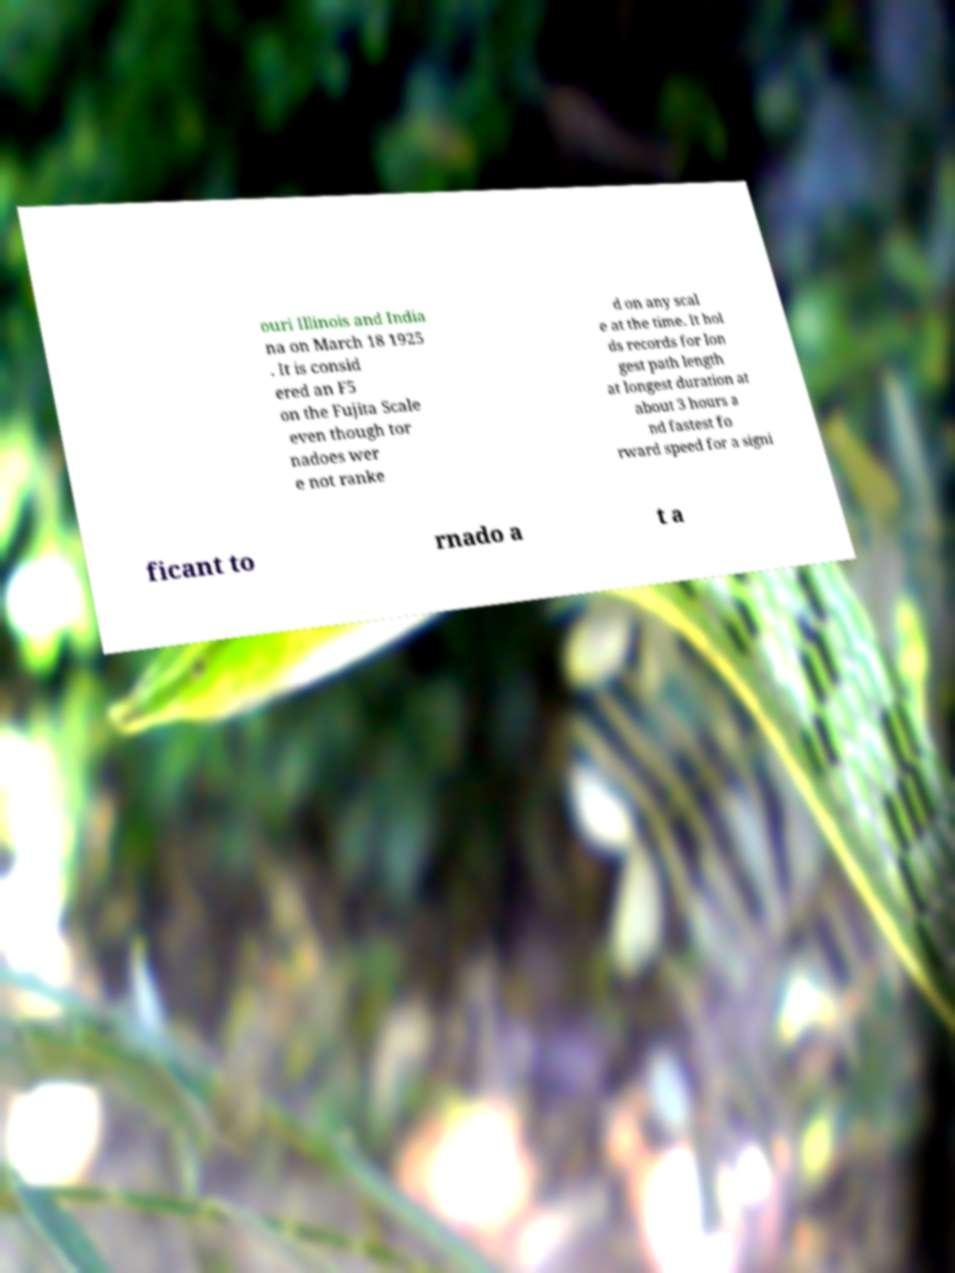Please identify and transcribe the text found in this image. ouri Illinois and India na on March 18 1925 . It is consid ered an F5 on the Fujita Scale even though tor nadoes wer e not ranke d on any scal e at the time. It hol ds records for lon gest path length at longest duration at about 3 hours a nd fastest fo rward speed for a signi ficant to rnado a t a 